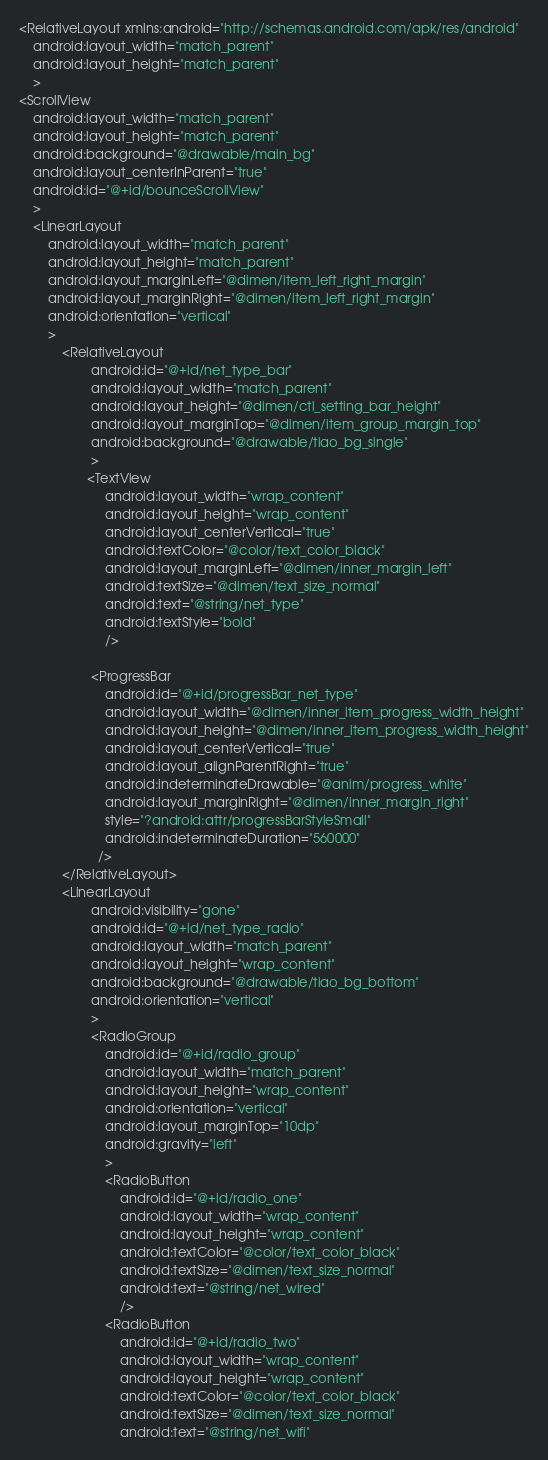Convert code to text. <code><loc_0><loc_0><loc_500><loc_500><_XML_><RelativeLayout xmlns:android="http://schemas.android.com/apk/res/android"
    android:layout_width="match_parent"
    android:layout_height="match_parent"
    >
<ScrollView 
    android:layout_width="match_parent"
    android:layout_height="match_parent"
    android:background="@drawable/main_bg"
    android:layout_centerInParent="true"
    android:id="@+id/bounceScrollView"
    > 
    <LinearLayout 
        android:layout_width="match_parent"
        android:layout_height="match_parent"
        android:layout_marginLeft="@dimen/item_left_right_margin"
		android:layout_marginRight="@dimen/item_left_right_margin"
		android:orientation="vertical"
        >
    		<RelativeLayout
		            android:id="@+id/net_type_bar"
		            android:layout_width="match_parent"
		            android:layout_height="@dimen/ctl_setting_bar_height"
		            android:layout_marginTop="@dimen/item_group_margin_top"
		            android:background="@drawable/tiao_bg_single"
		            >
		           <TextView 
	                    android:layout_width="wrap_content"
	                    android:layout_height="wrap_content"
	                    android:layout_centerVertical="true"
	                    android:textColor="@color/text_color_black"
	                    android:layout_marginLeft="@dimen/inner_margin_left"
	                    android:textSize="@dimen/text_size_normal"
	                    android:text="@string/net_type"
	                    android:textStyle="bold"
	                    />
                
	                <ProgressBar
			            android:id="@+id/progressBar_net_type"
			            android:layout_width="@dimen/inner_item_progress_width_height"
			            android:layout_height="@dimen/inner_item_progress_width_height"
			            android:layout_centerVertical="true"
	                    android:layout_alignParentRight="true"
			            android:indeterminateDrawable="@anim/progress_white"
			            android:layout_marginRight="@dimen/inner_margin_right"
			            style="?android:attr/progressBarStyleSmall" 
			            android:indeterminateDuration="560000"
			          />
			</RelativeLayout>
			<LinearLayout 
			    	android:visibility="gone"
			    	android:id="@+id/net_type_radio"
		            android:layout_width="match_parent"
		            android:layout_height="wrap_content"
		            android:background="@drawable/tiao_bg_bottom"
		            android:orientation="vertical"
		            >
		            <RadioGroup 
		                android:id="@+id/radio_group"
		                android:layout_width="match_parent"
		                android:layout_height="wrap_content"
		                android:orientation="vertical"
		                android:layout_marginTop="10dp"
		                android:gravity="left"
		                >
		                <RadioButton 
		                    android:id="@+id/radio_one"
		                    android:layout_width="wrap_content"
		                    android:layout_height="wrap_content"
		                    android:textColor="@color/text_color_black"
		                    android:textSize="@dimen/text_size_normal"
		                    android:text="@string/net_wired"
		                    />
		                <RadioButton 
		                    android:id="@+id/radio_two"
		                    android:layout_width="wrap_content"
		                    android:layout_height="wrap_content"
		                    android:textColor="@color/text_color_black"
		                    android:textSize="@dimen/text_size_normal"
		                    android:text="@string/net_wifi"</code> 